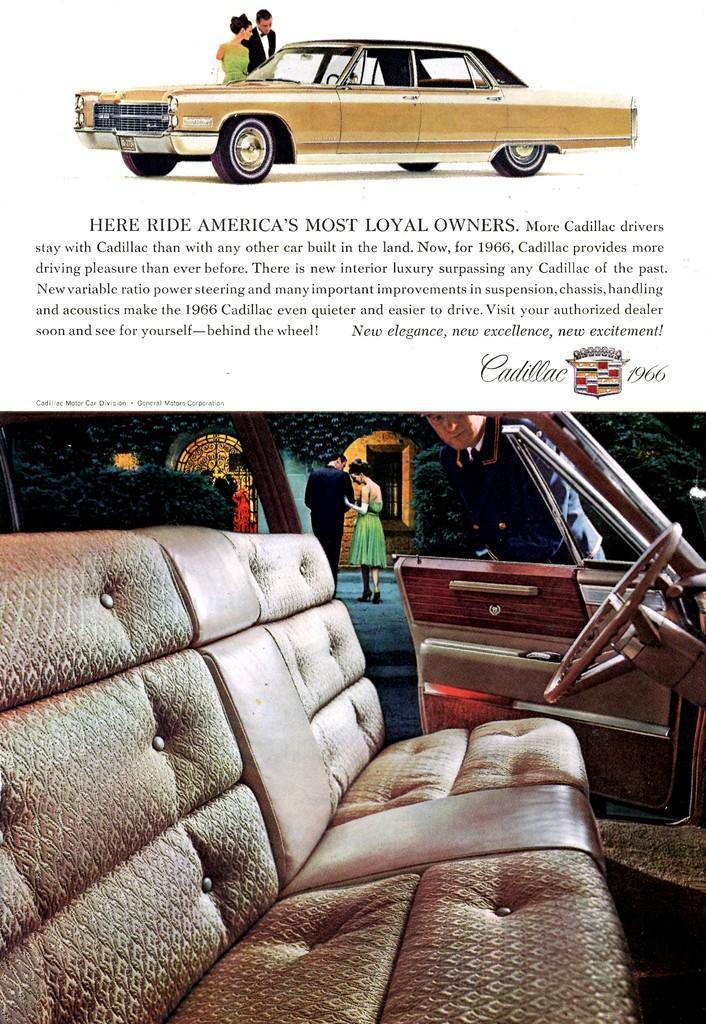Describe this image in one or two sentences. This image consists of a poster. At the bottom I can see an image of inside view of a vehicle. At the top of it I can see some text and also I can see an edited image of a car and two persons. 